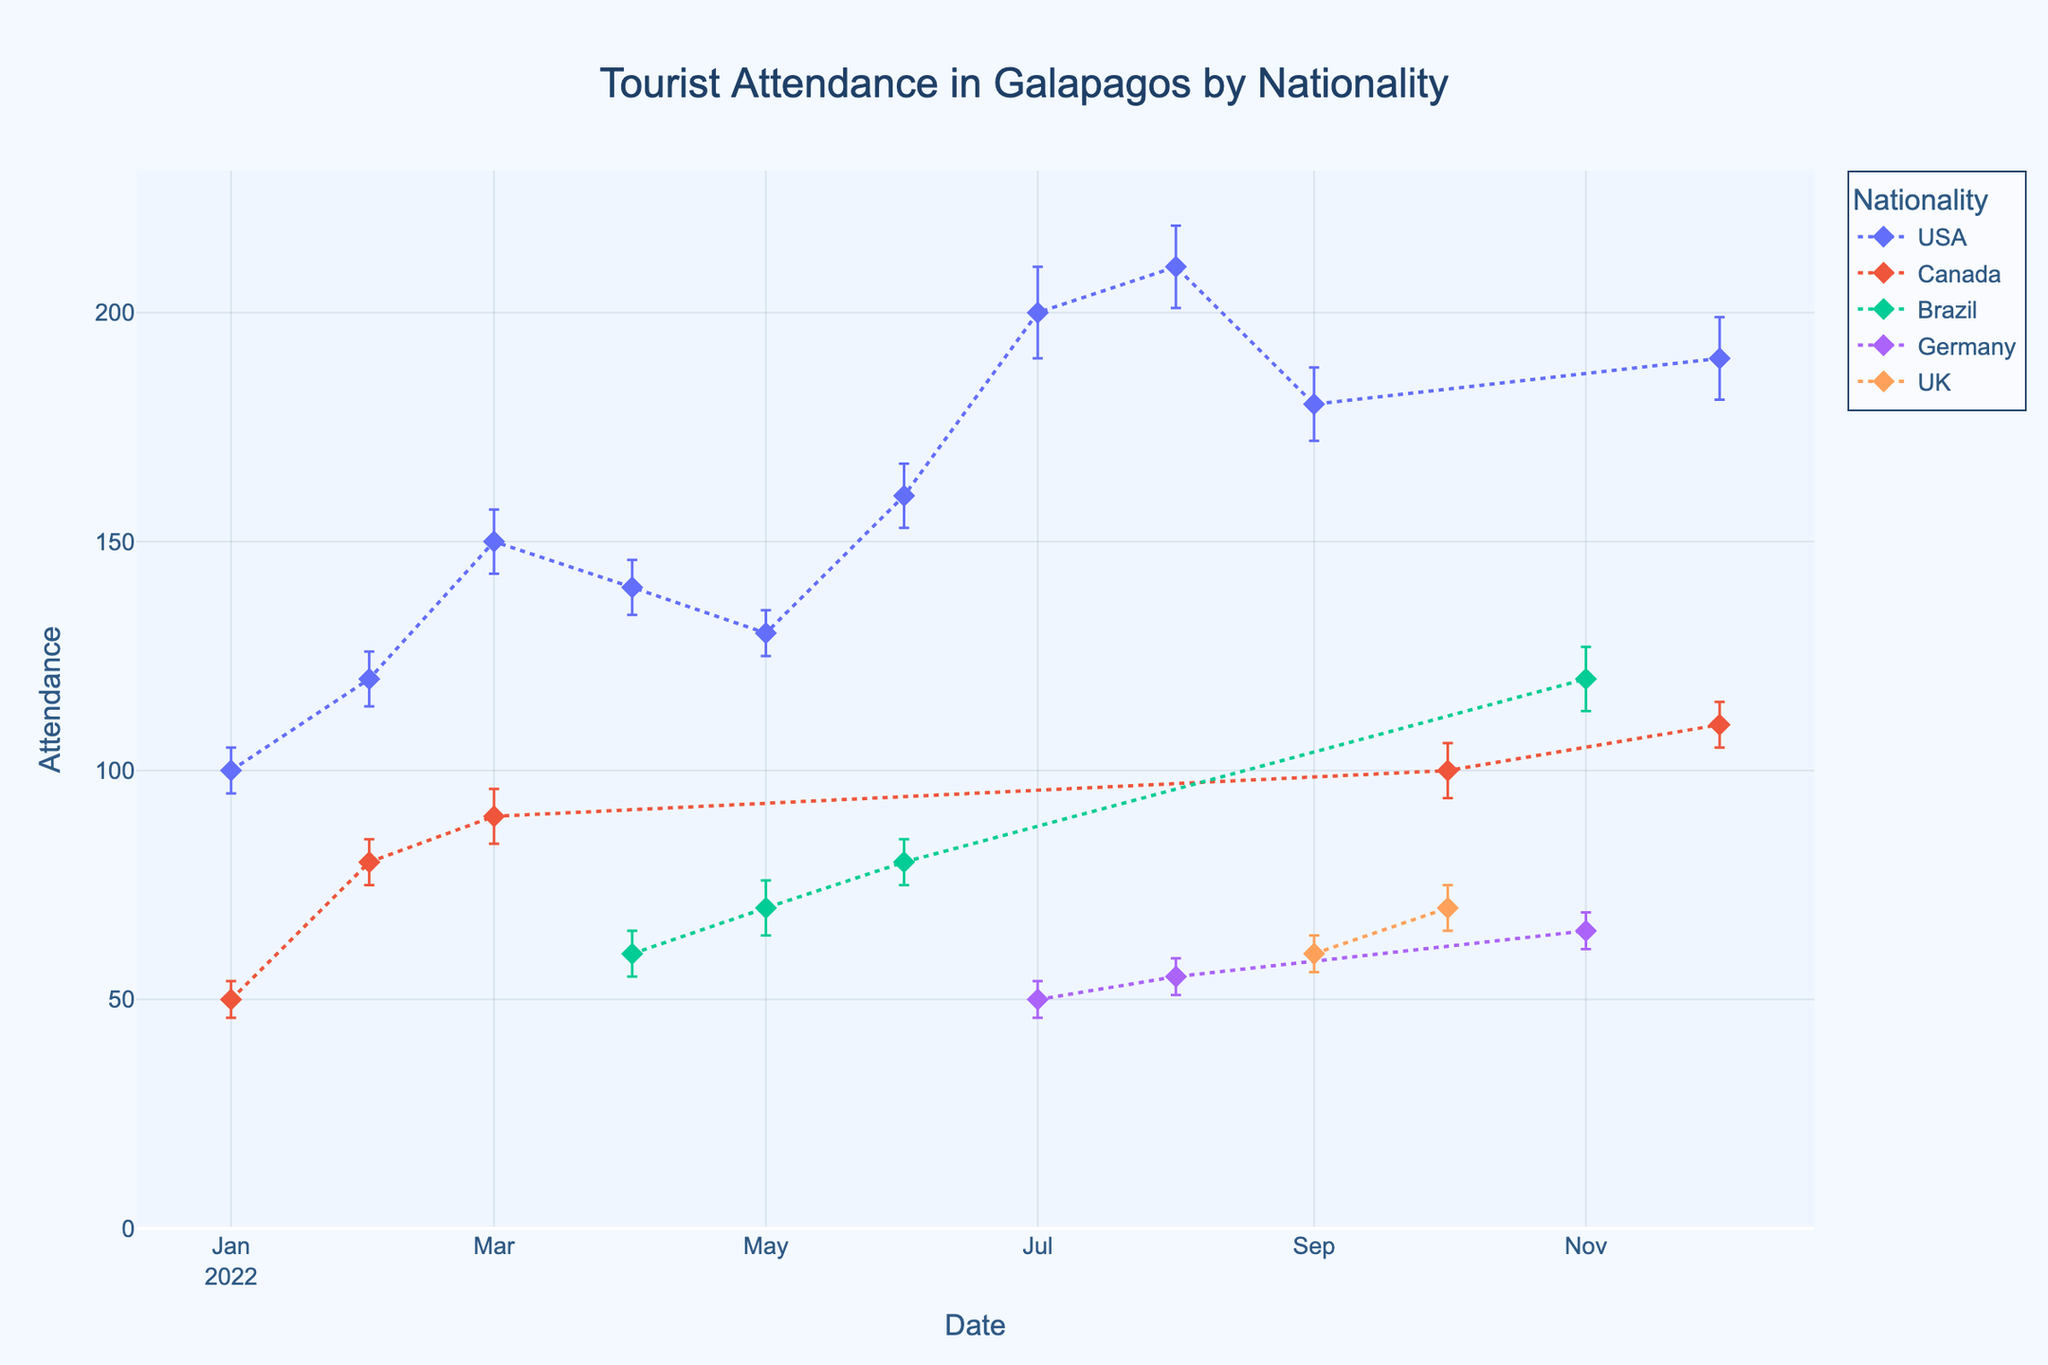What nationality had the highest peak attendance? Observe the scatter plot and identify the nationality with the highest attendance data point. The USA shows the highest peak attendance in July 2022 with around 210.
Answer: USA Which month had the greatest variety of nationalities attending? Look for the month with the most different markers/traces. November 2022 shows the greatest variety with Brazil and Germany.
Answer: November In which month did Brazilian tourists first appear in this dataset? Find the first occurrence of Brazil on the x-axis. Brazilian tourists first appear in April 2022.
Answer: April 2022 What is the average attendance for Canadian tourists based on the data? Calculate the average of the attendance for Canadian tourists. The attendance values are 50, 80, 90, 100, and 110. The average is (50+80+90+100+110)/5 = 86.
Answer: 86 Which nationality had the lowest attendance in any given month? Look at the lowest attendance value among all points and identify the nationality. German tourists had the lowest attendance with 50 in July 2022.
Answer: Germany When did the attendance for UK tourists peak? Identify the highest data point for UK tourists. UK attendance peaked in October 2022 with 70.
Answer: October 2022 Compare the attendance and error bars in July 2022 for USA tourists to German tourists. Examine the data points for July 2022 and compare the attendance and error bars. USA had an attendance of 200 with an error of 10, and Germany had an attendance of 50 with an error of 4.
Answer: USA: 200 (±10), Germany: 50 (±4) How does the error margin for Brazilian tourists change over time? Analyze the error bars for Brazilian tourists across different months. Brazilian tourists had error margins of 5, 6, 5, and 7 in April, May, June, and November, respectively. The error margin slightly increases over time.
Answer: Increasing What is the total attendance of USA tourists over the entire year? Sum all the attendance values for USA tourists in the dataset. The total attendance is 100 + 120 + 150 + 140 + 130 + 160 + 200 + 210 + 180 + 190 = 1580.
Answer: 1580 